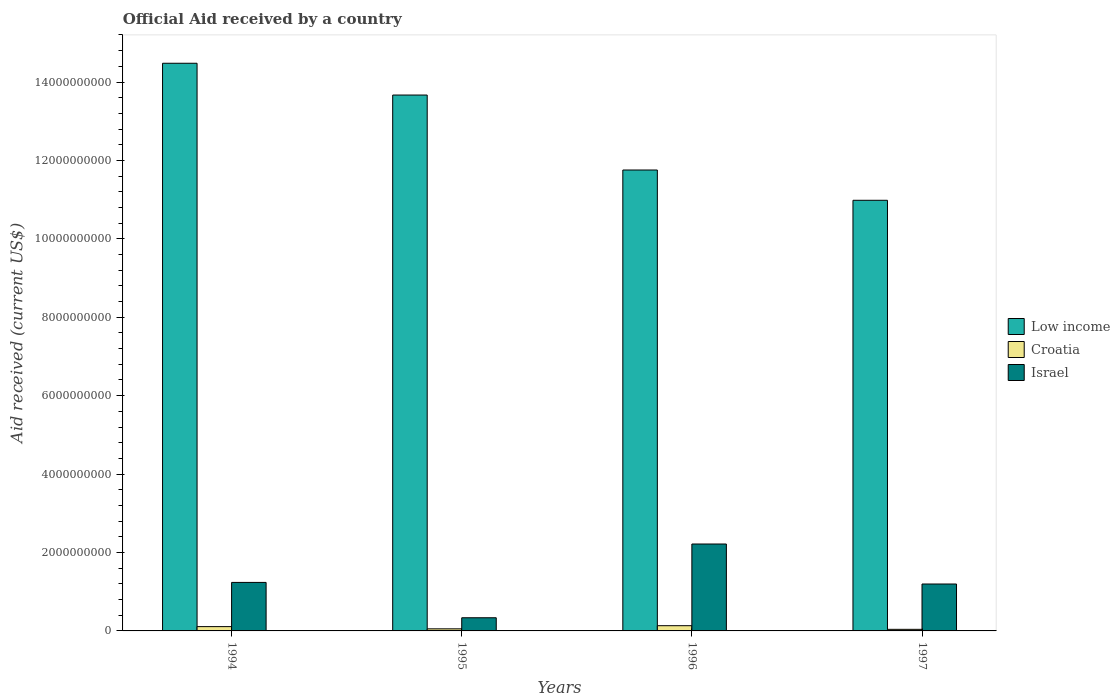Are the number of bars per tick equal to the number of legend labels?
Give a very brief answer. Yes. Are the number of bars on each tick of the X-axis equal?
Provide a short and direct response. Yes. How many bars are there on the 2nd tick from the right?
Ensure brevity in your answer.  3. What is the label of the 1st group of bars from the left?
Provide a succinct answer. 1994. What is the net official aid received in Croatia in 1995?
Provide a succinct answer. 5.33e+07. Across all years, what is the maximum net official aid received in Low income?
Give a very brief answer. 1.45e+1. Across all years, what is the minimum net official aid received in Croatia?
Your answer should be compact. 4.04e+07. In which year was the net official aid received in Israel maximum?
Your answer should be compact. 1996. In which year was the net official aid received in Low income minimum?
Your answer should be very brief. 1997. What is the total net official aid received in Croatia in the graph?
Make the answer very short. 3.37e+08. What is the difference between the net official aid received in Croatia in 1994 and that in 1997?
Ensure brevity in your answer.  6.93e+07. What is the difference between the net official aid received in Croatia in 1996 and the net official aid received in Israel in 1995?
Make the answer very short. -2.02e+08. What is the average net official aid received in Israel per year?
Give a very brief answer. 1.25e+09. In the year 1995, what is the difference between the net official aid received in Israel and net official aid received in Croatia?
Provide a short and direct response. 2.82e+08. What is the ratio of the net official aid received in Low income in 1994 to that in 1996?
Your answer should be very brief. 1.23. What is the difference between the highest and the second highest net official aid received in Croatia?
Provide a succinct answer. 2.36e+07. What is the difference between the highest and the lowest net official aid received in Croatia?
Provide a short and direct response. 9.30e+07. In how many years, is the net official aid received in Low income greater than the average net official aid received in Low income taken over all years?
Offer a very short reply. 2. What does the 1st bar from the left in 1994 represents?
Your response must be concise. Low income. What does the 1st bar from the right in 1996 represents?
Make the answer very short. Israel. Does the graph contain any zero values?
Offer a very short reply. No. Does the graph contain grids?
Your response must be concise. No. What is the title of the graph?
Your answer should be very brief. Official Aid received by a country. What is the label or title of the X-axis?
Make the answer very short. Years. What is the label or title of the Y-axis?
Offer a terse response. Aid received (current US$). What is the Aid received (current US$) in Low income in 1994?
Offer a very short reply. 1.45e+1. What is the Aid received (current US$) of Croatia in 1994?
Your answer should be very brief. 1.10e+08. What is the Aid received (current US$) in Israel in 1994?
Make the answer very short. 1.24e+09. What is the Aid received (current US$) of Low income in 1995?
Your response must be concise. 1.37e+1. What is the Aid received (current US$) in Croatia in 1995?
Offer a terse response. 5.33e+07. What is the Aid received (current US$) of Israel in 1995?
Ensure brevity in your answer.  3.36e+08. What is the Aid received (current US$) in Low income in 1996?
Offer a very short reply. 1.18e+1. What is the Aid received (current US$) of Croatia in 1996?
Make the answer very short. 1.33e+08. What is the Aid received (current US$) in Israel in 1996?
Your answer should be very brief. 2.22e+09. What is the Aid received (current US$) in Low income in 1997?
Offer a very short reply. 1.10e+1. What is the Aid received (current US$) of Croatia in 1997?
Ensure brevity in your answer.  4.04e+07. What is the Aid received (current US$) in Israel in 1997?
Make the answer very short. 1.20e+09. Across all years, what is the maximum Aid received (current US$) of Low income?
Offer a terse response. 1.45e+1. Across all years, what is the maximum Aid received (current US$) in Croatia?
Your response must be concise. 1.33e+08. Across all years, what is the maximum Aid received (current US$) of Israel?
Offer a very short reply. 2.22e+09. Across all years, what is the minimum Aid received (current US$) in Low income?
Your response must be concise. 1.10e+1. Across all years, what is the minimum Aid received (current US$) of Croatia?
Keep it short and to the point. 4.04e+07. Across all years, what is the minimum Aid received (current US$) in Israel?
Offer a terse response. 3.36e+08. What is the total Aid received (current US$) in Low income in the graph?
Provide a short and direct response. 5.09e+1. What is the total Aid received (current US$) of Croatia in the graph?
Your answer should be compact. 3.37e+08. What is the total Aid received (current US$) in Israel in the graph?
Keep it short and to the point. 4.99e+09. What is the difference between the Aid received (current US$) in Low income in 1994 and that in 1995?
Provide a succinct answer. 8.10e+08. What is the difference between the Aid received (current US$) in Croatia in 1994 and that in 1995?
Your answer should be compact. 5.64e+07. What is the difference between the Aid received (current US$) of Israel in 1994 and that in 1995?
Make the answer very short. 9.02e+08. What is the difference between the Aid received (current US$) of Low income in 1994 and that in 1996?
Keep it short and to the point. 2.72e+09. What is the difference between the Aid received (current US$) of Croatia in 1994 and that in 1996?
Provide a succinct answer. -2.36e+07. What is the difference between the Aid received (current US$) of Israel in 1994 and that in 1996?
Ensure brevity in your answer.  -9.80e+08. What is the difference between the Aid received (current US$) of Low income in 1994 and that in 1997?
Offer a terse response. 3.50e+09. What is the difference between the Aid received (current US$) of Croatia in 1994 and that in 1997?
Provide a succinct answer. 6.93e+07. What is the difference between the Aid received (current US$) in Israel in 1994 and that in 1997?
Make the answer very short. 4.08e+07. What is the difference between the Aid received (current US$) in Low income in 1995 and that in 1996?
Provide a short and direct response. 1.91e+09. What is the difference between the Aid received (current US$) of Croatia in 1995 and that in 1996?
Give a very brief answer. -8.00e+07. What is the difference between the Aid received (current US$) in Israel in 1995 and that in 1996?
Provide a succinct answer. -1.88e+09. What is the difference between the Aid received (current US$) in Low income in 1995 and that in 1997?
Ensure brevity in your answer.  2.68e+09. What is the difference between the Aid received (current US$) of Croatia in 1995 and that in 1997?
Offer a terse response. 1.29e+07. What is the difference between the Aid received (current US$) of Israel in 1995 and that in 1997?
Your answer should be very brief. -8.61e+08. What is the difference between the Aid received (current US$) of Low income in 1996 and that in 1997?
Give a very brief answer. 7.72e+08. What is the difference between the Aid received (current US$) in Croatia in 1996 and that in 1997?
Keep it short and to the point. 9.30e+07. What is the difference between the Aid received (current US$) of Israel in 1996 and that in 1997?
Make the answer very short. 1.02e+09. What is the difference between the Aid received (current US$) in Low income in 1994 and the Aid received (current US$) in Croatia in 1995?
Provide a short and direct response. 1.44e+1. What is the difference between the Aid received (current US$) in Low income in 1994 and the Aid received (current US$) in Israel in 1995?
Your answer should be compact. 1.41e+1. What is the difference between the Aid received (current US$) of Croatia in 1994 and the Aid received (current US$) of Israel in 1995?
Your response must be concise. -2.26e+08. What is the difference between the Aid received (current US$) in Low income in 1994 and the Aid received (current US$) in Croatia in 1996?
Provide a succinct answer. 1.43e+1. What is the difference between the Aid received (current US$) in Low income in 1994 and the Aid received (current US$) in Israel in 1996?
Your answer should be very brief. 1.23e+1. What is the difference between the Aid received (current US$) of Croatia in 1994 and the Aid received (current US$) of Israel in 1996?
Your response must be concise. -2.11e+09. What is the difference between the Aid received (current US$) of Low income in 1994 and the Aid received (current US$) of Croatia in 1997?
Ensure brevity in your answer.  1.44e+1. What is the difference between the Aid received (current US$) of Low income in 1994 and the Aid received (current US$) of Israel in 1997?
Keep it short and to the point. 1.33e+1. What is the difference between the Aid received (current US$) in Croatia in 1994 and the Aid received (current US$) in Israel in 1997?
Make the answer very short. -1.09e+09. What is the difference between the Aid received (current US$) of Low income in 1995 and the Aid received (current US$) of Croatia in 1996?
Ensure brevity in your answer.  1.35e+1. What is the difference between the Aid received (current US$) of Low income in 1995 and the Aid received (current US$) of Israel in 1996?
Provide a succinct answer. 1.15e+1. What is the difference between the Aid received (current US$) of Croatia in 1995 and the Aid received (current US$) of Israel in 1996?
Provide a short and direct response. -2.16e+09. What is the difference between the Aid received (current US$) of Low income in 1995 and the Aid received (current US$) of Croatia in 1997?
Provide a short and direct response. 1.36e+1. What is the difference between the Aid received (current US$) of Low income in 1995 and the Aid received (current US$) of Israel in 1997?
Provide a short and direct response. 1.25e+1. What is the difference between the Aid received (current US$) of Croatia in 1995 and the Aid received (current US$) of Israel in 1997?
Provide a succinct answer. -1.14e+09. What is the difference between the Aid received (current US$) in Low income in 1996 and the Aid received (current US$) in Croatia in 1997?
Offer a very short reply. 1.17e+1. What is the difference between the Aid received (current US$) in Low income in 1996 and the Aid received (current US$) in Israel in 1997?
Offer a very short reply. 1.06e+1. What is the difference between the Aid received (current US$) in Croatia in 1996 and the Aid received (current US$) in Israel in 1997?
Provide a succinct answer. -1.06e+09. What is the average Aid received (current US$) in Low income per year?
Provide a succinct answer. 1.27e+1. What is the average Aid received (current US$) in Croatia per year?
Offer a very short reply. 8.42e+07. What is the average Aid received (current US$) of Israel per year?
Your answer should be compact. 1.25e+09. In the year 1994, what is the difference between the Aid received (current US$) of Low income and Aid received (current US$) of Croatia?
Make the answer very short. 1.44e+1. In the year 1994, what is the difference between the Aid received (current US$) of Low income and Aid received (current US$) of Israel?
Provide a short and direct response. 1.32e+1. In the year 1994, what is the difference between the Aid received (current US$) of Croatia and Aid received (current US$) of Israel?
Keep it short and to the point. -1.13e+09. In the year 1995, what is the difference between the Aid received (current US$) in Low income and Aid received (current US$) in Croatia?
Make the answer very short. 1.36e+1. In the year 1995, what is the difference between the Aid received (current US$) in Low income and Aid received (current US$) in Israel?
Provide a short and direct response. 1.33e+1. In the year 1995, what is the difference between the Aid received (current US$) in Croatia and Aid received (current US$) in Israel?
Provide a short and direct response. -2.82e+08. In the year 1996, what is the difference between the Aid received (current US$) in Low income and Aid received (current US$) in Croatia?
Your answer should be very brief. 1.16e+1. In the year 1996, what is the difference between the Aid received (current US$) of Low income and Aid received (current US$) of Israel?
Make the answer very short. 9.54e+09. In the year 1996, what is the difference between the Aid received (current US$) of Croatia and Aid received (current US$) of Israel?
Keep it short and to the point. -2.08e+09. In the year 1997, what is the difference between the Aid received (current US$) of Low income and Aid received (current US$) of Croatia?
Offer a very short reply. 1.09e+1. In the year 1997, what is the difference between the Aid received (current US$) in Low income and Aid received (current US$) in Israel?
Offer a very short reply. 9.79e+09. In the year 1997, what is the difference between the Aid received (current US$) in Croatia and Aid received (current US$) in Israel?
Offer a very short reply. -1.16e+09. What is the ratio of the Aid received (current US$) in Low income in 1994 to that in 1995?
Your answer should be compact. 1.06. What is the ratio of the Aid received (current US$) in Croatia in 1994 to that in 1995?
Your response must be concise. 2.06. What is the ratio of the Aid received (current US$) in Israel in 1994 to that in 1995?
Give a very brief answer. 3.69. What is the ratio of the Aid received (current US$) of Low income in 1994 to that in 1996?
Ensure brevity in your answer.  1.23. What is the ratio of the Aid received (current US$) of Croatia in 1994 to that in 1996?
Make the answer very short. 0.82. What is the ratio of the Aid received (current US$) of Israel in 1994 to that in 1996?
Provide a succinct answer. 0.56. What is the ratio of the Aid received (current US$) in Low income in 1994 to that in 1997?
Your answer should be compact. 1.32. What is the ratio of the Aid received (current US$) in Croatia in 1994 to that in 1997?
Your response must be concise. 2.72. What is the ratio of the Aid received (current US$) of Israel in 1994 to that in 1997?
Your response must be concise. 1.03. What is the ratio of the Aid received (current US$) in Low income in 1995 to that in 1996?
Make the answer very short. 1.16. What is the ratio of the Aid received (current US$) in Croatia in 1995 to that in 1996?
Ensure brevity in your answer.  0.4. What is the ratio of the Aid received (current US$) of Israel in 1995 to that in 1996?
Ensure brevity in your answer.  0.15. What is the ratio of the Aid received (current US$) of Low income in 1995 to that in 1997?
Your answer should be very brief. 1.24. What is the ratio of the Aid received (current US$) in Croatia in 1995 to that in 1997?
Provide a short and direct response. 1.32. What is the ratio of the Aid received (current US$) of Israel in 1995 to that in 1997?
Provide a succinct answer. 0.28. What is the ratio of the Aid received (current US$) in Low income in 1996 to that in 1997?
Offer a very short reply. 1.07. What is the ratio of the Aid received (current US$) of Croatia in 1996 to that in 1997?
Your answer should be very brief. 3.3. What is the ratio of the Aid received (current US$) of Israel in 1996 to that in 1997?
Give a very brief answer. 1.85. What is the difference between the highest and the second highest Aid received (current US$) in Low income?
Give a very brief answer. 8.10e+08. What is the difference between the highest and the second highest Aid received (current US$) in Croatia?
Offer a terse response. 2.36e+07. What is the difference between the highest and the second highest Aid received (current US$) in Israel?
Ensure brevity in your answer.  9.80e+08. What is the difference between the highest and the lowest Aid received (current US$) of Low income?
Provide a succinct answer. 3.50e+09. What is the difference between the highest and the lowest Aid received (current US$) of Croatia?
Your response must be concise. 9.30e+07. What is the difference between the highest and the lowest Aid received (current US$) in Israel?
Keep it short and to the point. 1.88e+09. 